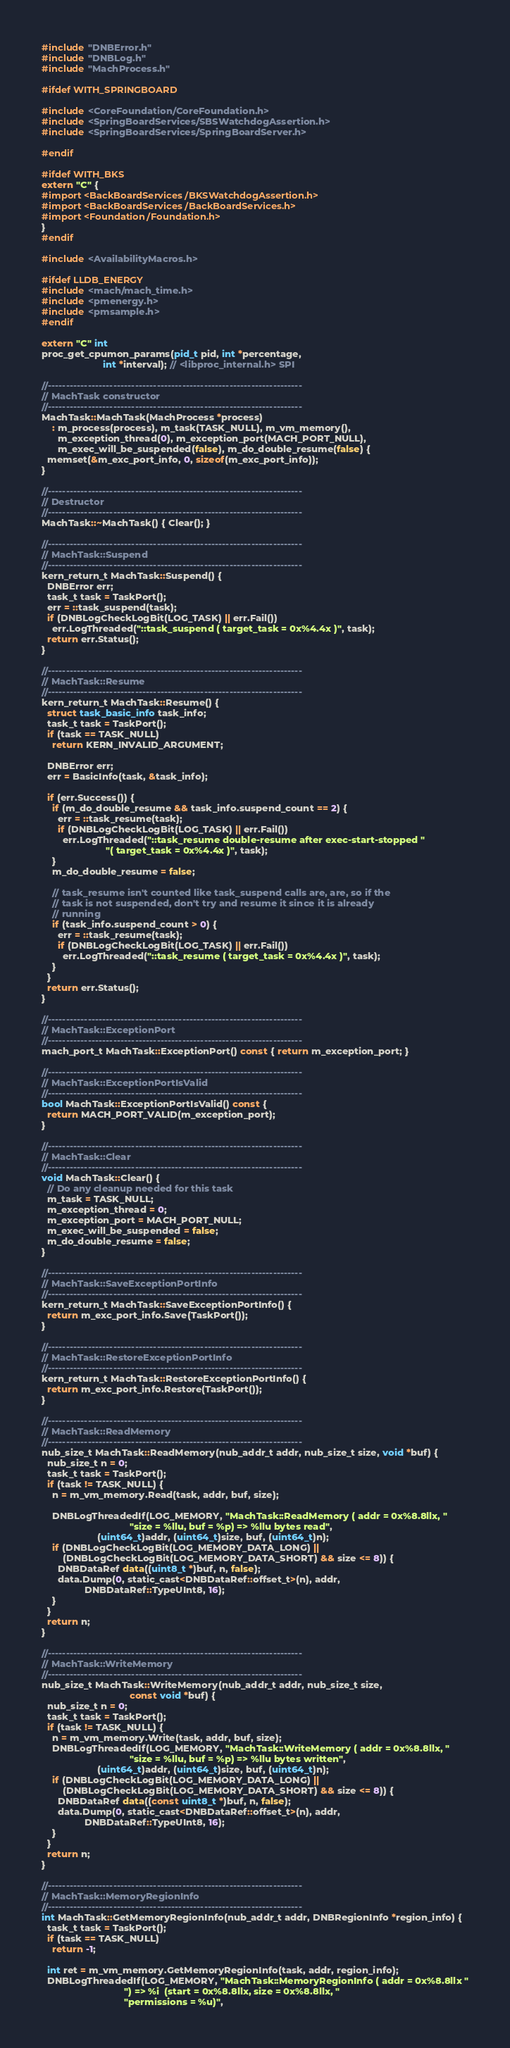Convert code to text. <code><loc_0><loc_0><loc_500><loc_500><_ObjectiveC_>#include "DNBError.h"
#include "DNBLog.h"
#include "MachProcess.h"

#ifdef WITH_SPRINGBOARD

#include <CoreFoundation/CoreFoundation.h>
#include <SpringBoardServices/SBSWatchdogAssertion.h>
#include <SpringBoardServices/SpringBoardServer.h>

#endif

#ifdef WITH_BKS
extern "C" {
#import <BackBoardServices/BKSWatchdogAssertion.h>
#import <BackBoardServices/BackBoardServices.h>
#import <Foundation/Foundation.h>
}
#endif

#include <AvailabilityMacros.h>

#ifdef LLDB_ENERGY
#include <mach/mach_time.h>
#include <pmenergy.h>
#include <pmsample.h>
#endif

extern "C" int
proc_get_cpumon_params(pid_t pid, int *percentage,
                       int *interval); // <libproc_internal.h> SPI

//----------------------------------------------------------------------
// MachTask constructor
//----------------------------------------------------------------------
MachTask::MachTask(MachProcess *process)
    : m_process(process), m_task(TASK_NULL), m_vm_memory(),
      m_exception_thread(0), m_exception_port(MACH_PORT_NULL),
      m_exec_will_be_suspended(false), m_do_double_resume(false) {
  memset(&m_exc_port_info, 0, sizeof(m_exc_port_info));
}

//----------------------------------------------------------------------
// Destructor
//----------------------------------------------------------------------
MachTask::~MachTask() { Clear(); }

//----------------------------------------------------------------------
// MachTask::Suspend
//----------------------------------------------------------------------
kern_return_t MachTask::Suspend() {
  DNBError err;
  task_t task = TaskPort();
  err = ::task_suspend(task);
  if (DNBLogCheckLogBit(LOG_TASK) || err.Fail())
    err.LogThreaded("::task_suspend ( target_task = 0x%4.4x )", task);
  return err.Status();
}

//----------------------------------------------------------------------
// MachTask::Resume
//----------------------------------------------------------------------
kern_return_t MachTask::Resume() {
  struct task_basic_info task_info;
  task_t task = TaskPort();
  if (task == TASK_NULL)
    return KERN_INVALID_ARGUMENT;

  DNBError err;
  err = BasicInfo(task, &task_info);

  if (err.Success()) {
    if (m_do_double_resume && task_info.suspend_count == 2) {
      err = ::task_resume(task);
      if (DNBLogCheckLogBit(LOG_TASK) || err.Fail())
        err.LogThreaded("::task_resume double-resume after exec-start-stopped "
                        "( target_task = 0x%4.4x )", task);
    }
    m_do_double_resume = false;
      
    // task_resume isn't counted like task_suspend calls are, are, so if the
    // task is not suspended, don't try and resume it since it is already
    // running
    if (task_info.suspend_count > 0) {
      err = ::task_resume(task);
      if (DNBLogCheckLogBit(LOG_TASK) || err.Fail())
        err.LogThreaded("::task_resume ( target_task = 0x%4.4x )", task);
    }
  }
  return err.Status();
}

//----------------------------------------------------------------------
// MachTask::ExceptionPort
//----------------------------------------------------------------------
mach_port_t MachTask::ExceptionPort() const { return m_exception_port; }

//----------------------------------------------------------------------
// MachTask::ExceptionPortIsValid
//----------------------------------------------------------------------
bool MachTask::ExceptionPortIsValid() const {
  return MACH_PORT_VALID(m_exception_port);
}

//----------------------------------------------------------------------
// MachTask::Clear
//----------------------------------------------------------------------
void MachTask::Clear() {
  // Do any cleanup needed for this task
  m_task = TASK_NULL;
  m_exception_thread = 0;
  m_exception_port = MACH_PORT_NULL;
  m_exec_will_be_suspended = false;
  m_do_double_resume = false;
}

//----------------------------------------------------------------------
// MachTask::SaveExceptionPortInfo
//----------------------------------------------------------------------
kern_return_t MachTask::SaveExceptionPortInfo() {
  return m_exc_port_info.Save(TaskPort());
}

//----------------------------------------------------------------------
// MachTask::RestoreExceptionPortInfo
//----------------------------------------------------------------------
kern_return_t MachTask::RestoreExceptionPortInfo() {
  return m_exc_port_info.Restore(TaskPort());
}

//----------------------------------------------------------------------
// MachTask::ReadMemory
//----------------------------------------------------------------------
nub_size_t MachTask::ReadMemory(nub_addr_t addr, nub_size_t size, void *buf) {
  nub_size_t n = 0;
  task_t task = TaskPort();
  if (task != TASK_NULL) {
    n = m_vm_memory.Read(task, addr, buf, size);

    DNBLogThreadedIf(LOG_MEMORY, "MachTask::ReadMemory ( addr = 0x%8.8llx, "
                                 "size = %llu, buf = %p) => %llu bytes read",
                     (uint64_t)addr, (uint64_t)size, buf, (uint64_t)n);
    if (DNBLogCheckLogBit(LOG_MEMORY_DATA_LONG) ||
        (DNBLogCheckLogBit(LOG_MEMORY_DATA_SHORT) && size <= 8)) {
      DNBDataRef data((uint8_t *)buf, n, false);
      data.Dump(0, static_cast<DNBDataRef::offset_t>(n), addr,
                DNBDataRef::TypeUInt8, 16);
    }
  }
  return n;
}

//----------------------------------------------------------------------
// MachTask::WriteMemory
//----------------------------------------------------------------------
nub_size_t MachTask::WriteMemory(nub_addr_t addr, nub_size_t size,
                                 const void *buf) {
  nub_size_t n = 0;
  task_t task = TaskPort();
  if (task != TASK_NULL) {
    n = m_vm_memory.Write(task, addr, buf, size);
    DNBLogThreadedIf(LOG_MEMORY, "MachTask::WriteMemory ( addr = 0x%8.8llx, "
                                 "size = %llu, buf = %p) => %llu bytes written",
                     (uint64_t)addr, (uint64_t)size, buf, (uint64_t)n);
    if (DNBLogCheckLogBit(LOG_MEMORY_DATA_LONG) ||
        (DNBLogCheckLogBit(LOG_MEMORY_DATA_SHORT) && size <= 8)) {
      DNBDataRef data((const uint8_t *)buf, n, false);
      data.Dump(0, static_cast<DNBDataRef::offset_t>(n), addr,
                DNBDataRef::TypeUInt8, 16);
    }
  }
  return n;
}

//----------------------------------------------------------------------
// MachTask::MemoryRegionInfo
//----------------------------------------------------------------------
int MachTask::GetMemoryRegionInfo(nub_addr_t addr, DNBRegionInfo *region_info) {
  task_t task = TaskPort();
  if (task == TASK_NULL)
    return -1;

  int ret = m_vm_memory.GetMemoryRegionInfo(task, addr, region_info);
  DNBLogThreadedIf(LOG_MEMORY, "MachTask::MemoryRegionInfo ( addr = 0x%8.8llx "
                               ") => %i  (start = 0x%8.8llx, size = 0x%8.8llx, "
                               "permissions = %u)",</code> 